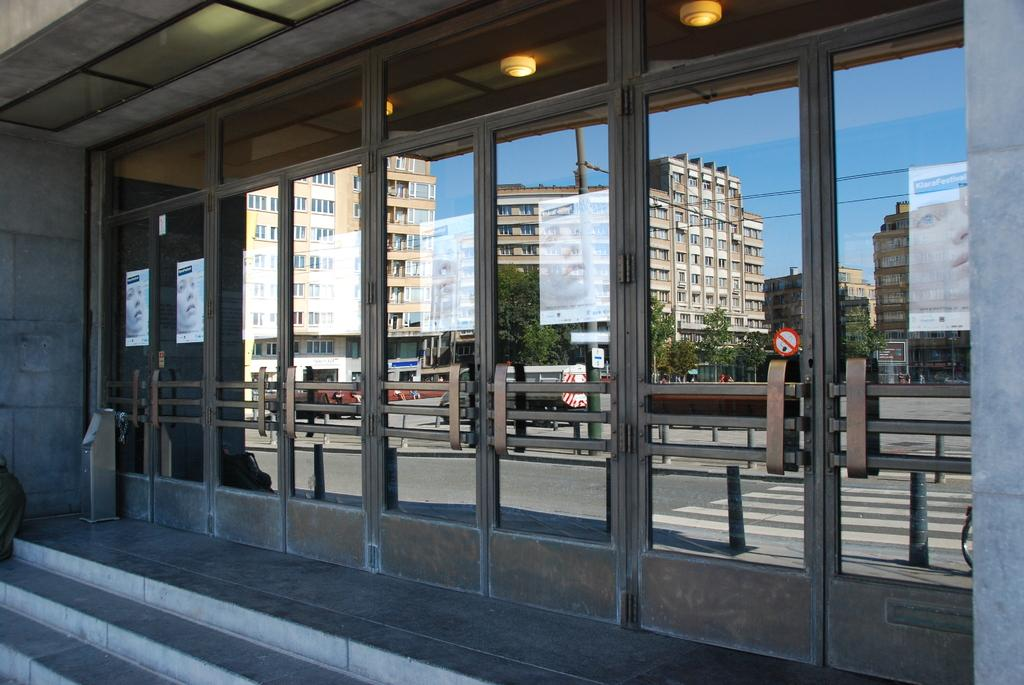What type of structures can be seen in the image? There are buildings in the image. What can be seen illuminating the area in the image? There are lights in the image. What are some objects that might be used for displaying information or advertisements? Boards and banners are present in the image. What type of transportation is visible on the road in the image? Vehicles are visible on the road in the image. What type of architectural feature can be seen in the image? Railings and stairs are visible in the image. What type of vegetation is present in the image? Trees are in the image. What type of infrastructure can be seen supporting wires in the image? Poles are present in the image, and wires are visible along with the poles. What type of amusement can be seen being used to rub the hammer in the image? There is no amusement, rubbing, or hammer present in the image. 